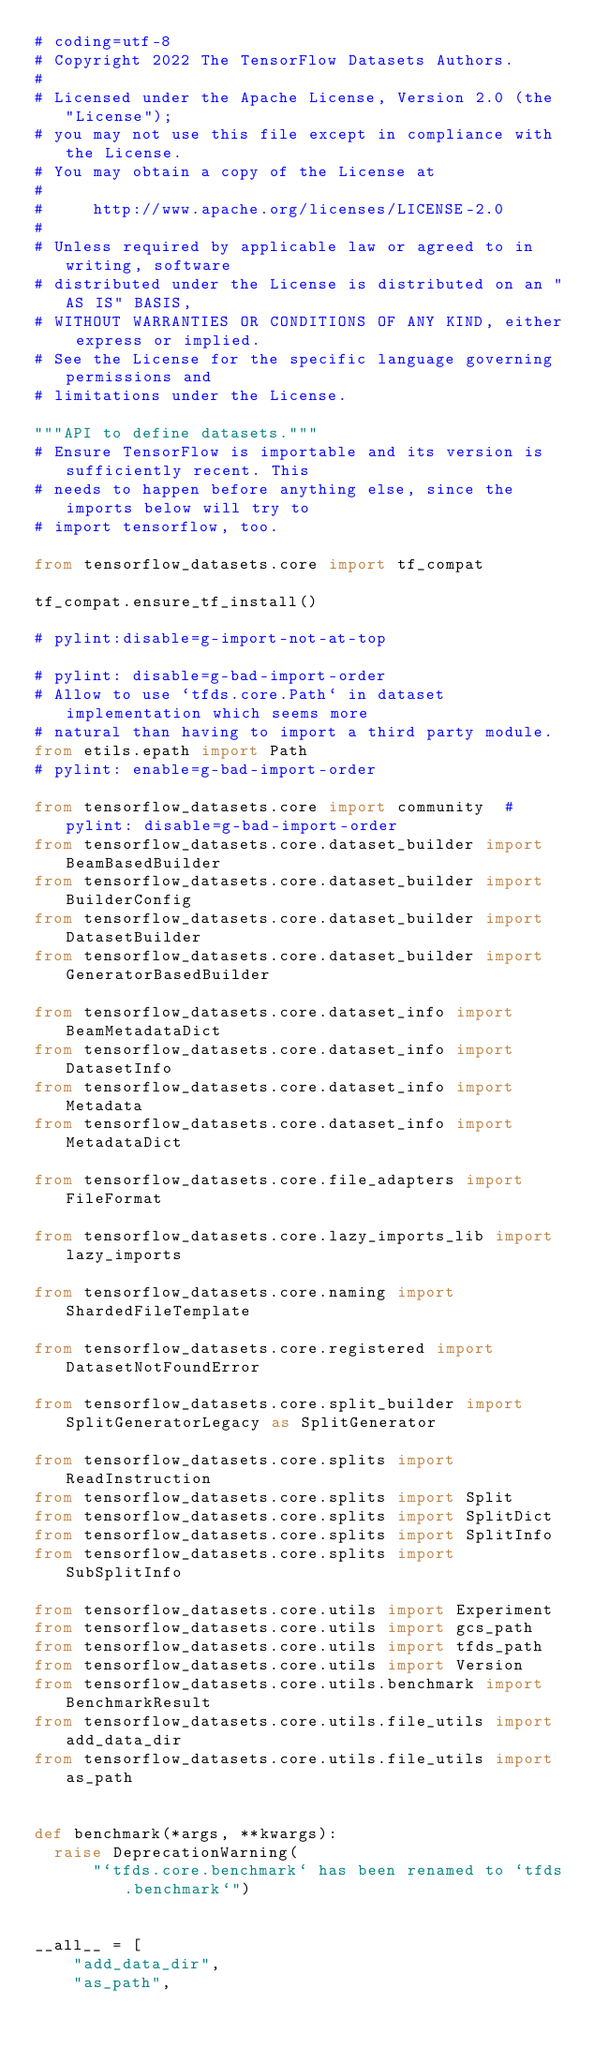<code> <loc_0><loc_0><loc_500><loc_500><_Python_># coding=utf-8
# Copyright 2022 The TensorFlow Datasets Authors.
#
# Licensed under the Apache License, Version 2.0 (the "License");
# you may not use this file except in compliance with the License.
# You may obtain a copy of the License at
#
#     http://www.apache.org/licenses/LICENSE-2.0
#
# Unless required by applicable law or agreed to in writing, software
# distributed under the License is distributed on an "AS IS" BASIS,
# WITHOUT WARRANTIES OR CONDITIONS OF ANY KIND, either express or implied.
# See the License for the specific language governing permissions and
# limitations under the License.

"""API to define datasets."""
# Ensure TensorFlow is importable and its version is sufficiently recent. This
# needs to happen before anything else, since the imports below will try to
# import tensorflow, too.

from tensorflow_datasets.core import tf_compat

tf_compat.ensure_tf_install()

# pylint:disable=g-import-not-at-top

# pylint: disable=g-bad-import-order
# Allow to use `tfds.core.Path` in dataset implementation which seems more
# natural than having to import a third party module.
from etils.epath import Path
# pylint: enable=g-bad-import-order

from tensorflow_datasets.core import community  # pylint: disable=g-bad-import-order
from tensorflow_datasets.core.dataset_builder import BeamBasedBuilder
from tensorflow_datasets.core.dataset_builder import BuilderConfig
from tensorflow_datasets.core.dataset_builder import DatasetBuilder
from tensorflow_datasets.core.dataset_builder import GeneratorBasedBuilder

from tensorflow_datasets.core.dataset_info import BeamMetadataDict
from tensorflow_datasets.core.dataset_info import DatasetInfo
from tensorflow_datasets.core.dataset_info import Metadata
from tensorflow_datasets.core.dataset_info import MetadataDict

from tensorflow_datasets.core.file_adapters import FileFormat

from tensorflow_datasets.core.lazy_imports_lib import lazy_imports

from tensorflow_datasets.core.naming import ShardedFileTemplate

from tensorflow_datasets.core.registered import DatasetNotFoundError

from tensorflow_datasets.core.split_builder import SplitGeneratorLegacy as SplitGenerator

from tensorflow_datasets.core.splits import ReadInstruction
from tensorflow_datasets.core.splits import Split
from tensorflow_datasets.core.splits import SplitDict
from tensorflow_datasets.core.splits import SplitInfo
from tensorflow_datasets.core.splits import SubSplitInfo

from tensorflow_datasets.core.utils import Experiment
from tensorflow_datasets.core.utils import gcs_path
from tensorflow_datasets.core.utils import tfds_path
from tensorflow_datasets.core.utils import Version
from tensorflow_datasets.core.utils.benchmark import BenchmarkResult
from tensorflow_datasets.core.utils.file_utils import add_data_dir
from tensorflow_datasets.core.utils.file_utils import as_path


def benchmark(*args, **kwargs):
  raise DeprecationWarning(
      "`tfds.core.benchmark` has been renamed to `tfds.benchmark`")


__all__ = [
    "add_data_dir",
    "as_path",</code> 